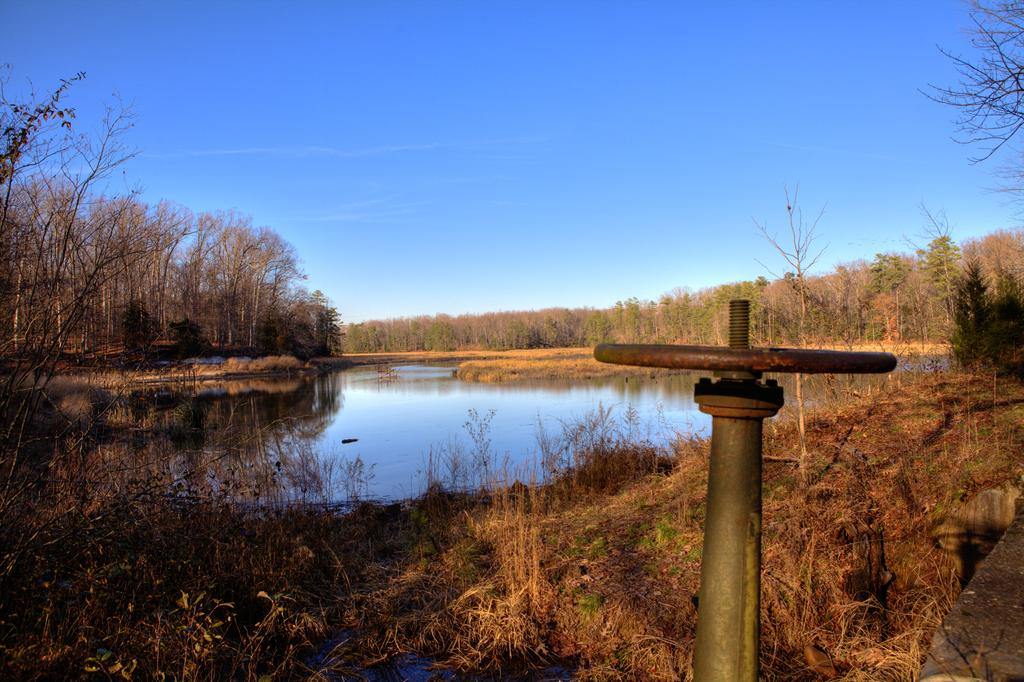What type of natural feature is present in the image? There is a lake in the image. What type of vegetation can be seen in the image? There are trees and plants in the image. Can you describe any man-made objects in the image? There is a pole-like object in the image. How does the pin shake in the image? There is no pin present in the image, so it cannot be shaking. 